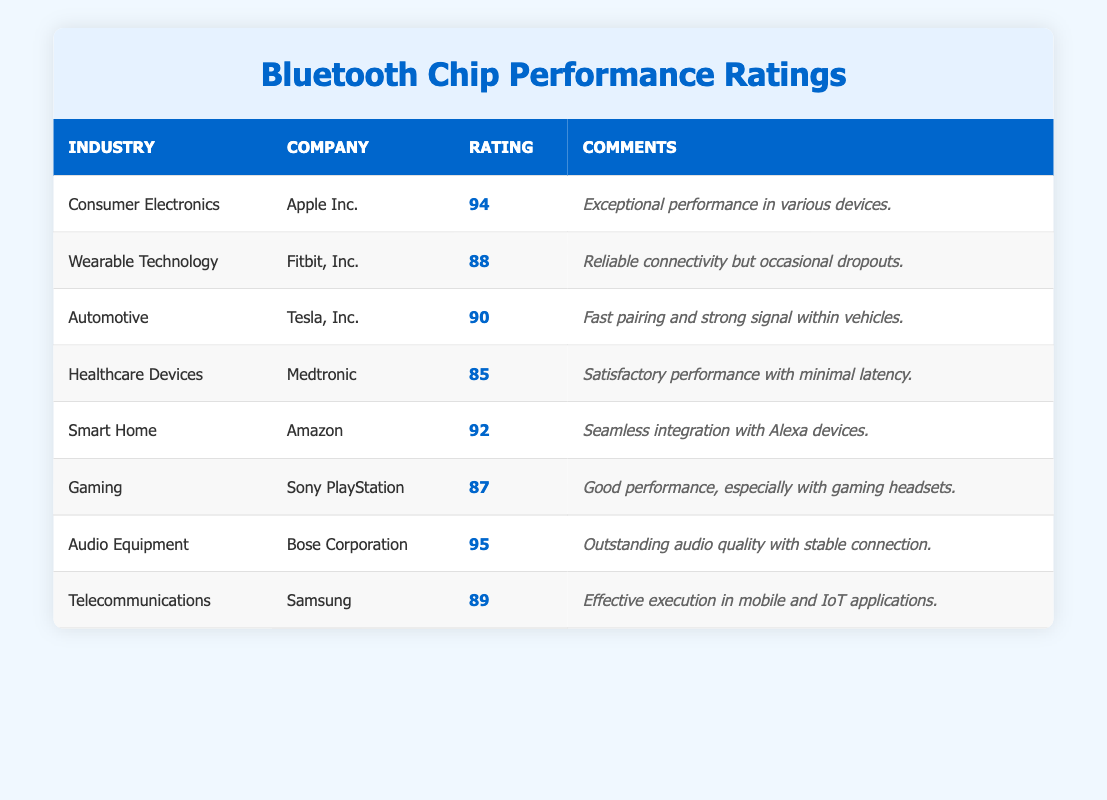What is the highest customer satisfaction rating among the companies listed? The ratings for the companies are 94, 88, 90, 85, 92, 87, 95, and 89. The highest value among these is 95, which is attributed to Bose Corporation.
Answer: 95 Which industry has the lowest customer satisfaction rating? The ratings listed are 94, 88, 90, 85, 92, 87, 95, and 89. The lowest rating is 85, which corresponds to the Healthcare Devices industry.
Answer: Healthcare Devices What is the average customer satisfaction rating for the Automotive and Wearable Technology industries? For Automotive, the rating is 90 and for Wearable Technology, it is 88. The average is calculated as (90 + 88) / 2 = 89.
Answer: 89 Is Apple Inc. rated higher than Samsung? Apple Inc. has a rating of 94, while Samsung's rating is 89. Since 94 is greater than 89, Apple Inc. is indeed rated higher.
Answer: Yes How many companies received a rating of 90 or above? The ratings of 90 or above are 94 (Apple Inc.), 90 (Tesla, Inc.), 92 (Amazon), and 95 (Bose Corporation), which totals four companies.
Answer: 4 Which company received the rating of 88, and what was the comment associated with it? The company with a rating of 88 is Fitbit, Inc., and the associated comment is "Reliable connectivity but occasional dropouts."
Answer: Fitbit, Inc If we consider the average customer satisfaction rating of all companies, what is it? The ratings are 94, 88, 90, 85, 92, 87, 95, and 89. First, we sum these values: 94 + 88 + 90 + 85 + 92 + 87 + 95 + 89 = 720. Since there are 8 companies, we divide 720 by 8, resulting in 90.
Answer: 90 Which industry shows a strong preference for fast pairing in Bluetooth chip performance? The Automotive industry has the comment "Fast pairing and strong signal within vehicles," indicating a strong preference for fast pairing.
Answer: Automotive Does the Gaming industry have a higher rating than Healthcare Devices? The Gaming industry is rated at 87, while Healthcare Devices is rated at 85. Since 87 is greater than 85, Gaming has a higher rating.
Answer: Yes 